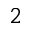Convert formula to latex. <formula><loc_0><loc_0><loc_500><loc_500>2</formula> 